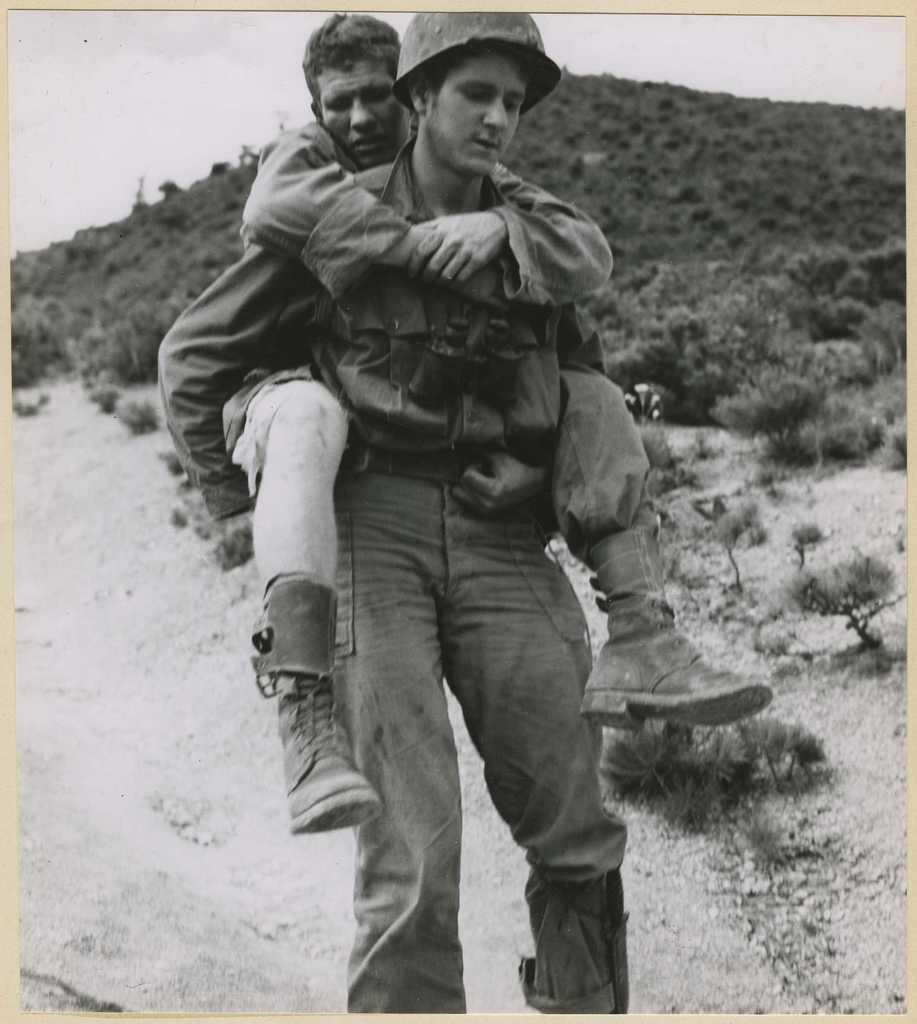What is happening between the two people in the image? There is a person carrying another person in the image. What is the setting of the image? The person is walking on a road. What can be seen beside the person on the road? There are plants beside the person on the road. What is visible in the background of the image? There is a mountain visible in the image. What type of furniture can be seen in the image? There is no furniture present in the image. What time of day is it in the image, considering the afternoon? The time of day cannot be determined from the image, as there is no reference to the sun or any other time-related indicators. 